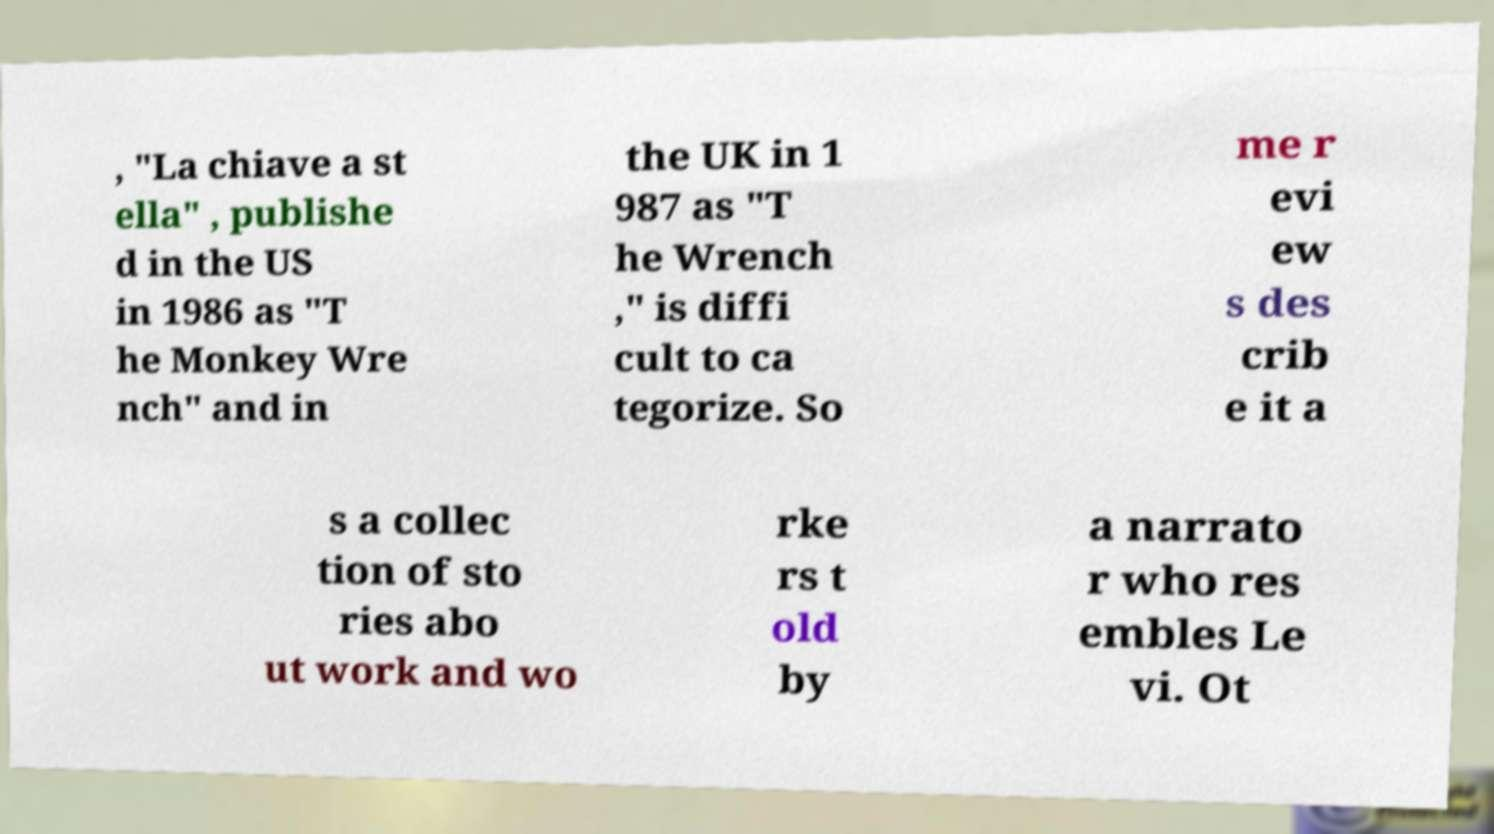Please identify and transcribe the text found in this image. , "La chiave a st ella" , publishe d in the US in 1986 as "T he Monkey Wre nch" and in the UK in 1 987 as "T he Wrench ," is diffi cult to ca tegorize. So me r evi ew s des crib e it a s a collec tion of sto ries abo ut work and wo rke rs t old by a narrato r who res embles Le vi. Ot 